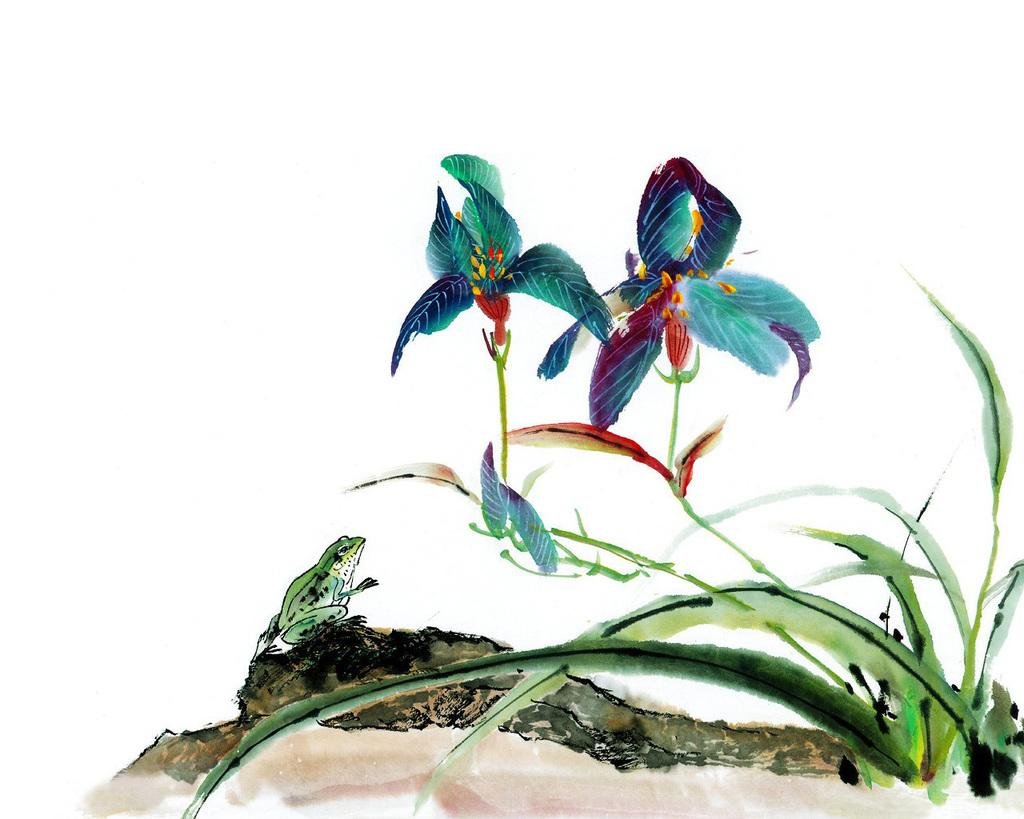What type of artwork is depicted in the image? The image appears to be a painting. What can be seen in the painting besides the artwork itself? There are plants with flowers and a frog sitting on a rock in the image. What type of noise can be heard coming from the society in the image? There is no reference to a society or any sounds in the image, so it's not possible to determine what, if any, noise might be heard. 